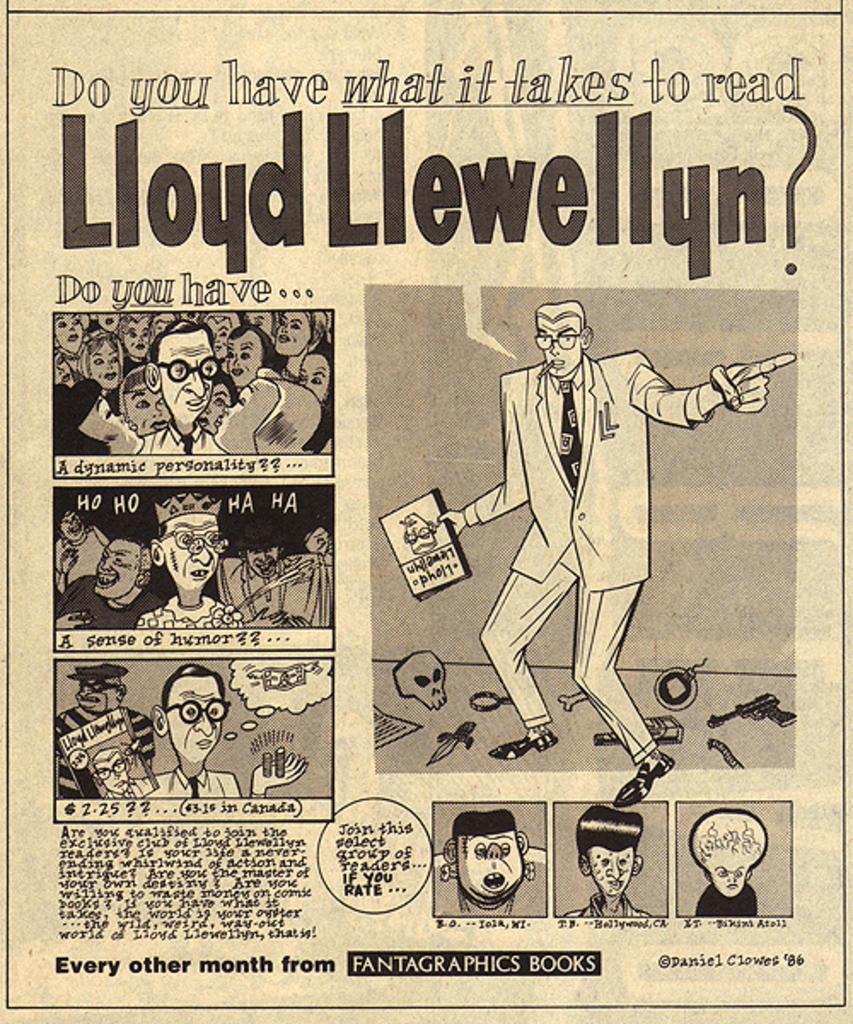What type of visual is the image? The image is a poster. What subjects are depicted in the poster? There are people and books depicted in the poster. Is there any text present in the poster? Yes, there is text present in the poster. How does the zephyr affect the people and books in the poster? There is no mention of a zephyr or any weather-related elements in the image, so it cannot be determined how it would affect the people and books in the poster. 